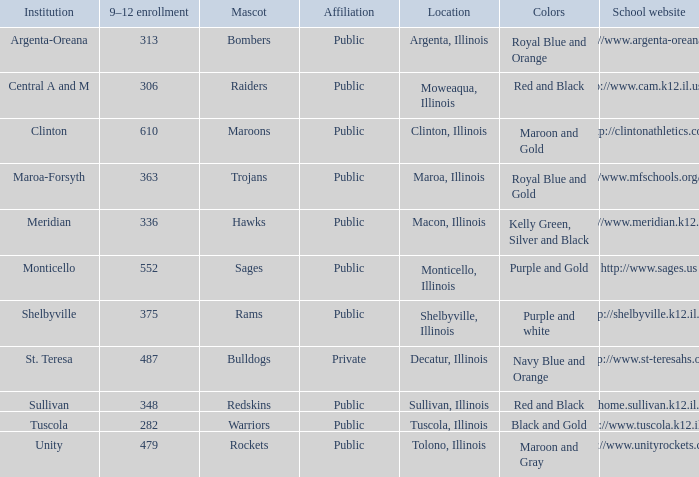Can you parse all the data within this table? {'header': ['Institution', '9–12 enrollment', 'Mascot', 'Affiliation', 'Location', 'Colors', 'School website'], 'rows': [['Argenta-Oreana', '313', 'Bombers', 'Public', 'Argenta, Illinois', 'Royal Blue and Orange', 'http://www.argenta-oreana.org'], ['Central A and M', '306', 'Raiders', 'Public', 'Moweaqua, Illinois', 'Red and Black', 'http://www.cam.k12.il.us/hs'], ['Clinton', '610', 'Maroons', 'Public', 'Clinton, Illinois', 'Maroon and Gold', 'http://clintonathletics.com'], ['Maroa-Forsyth', '363', 'Trojans', 'Public', 'Maroa, Illinois', 'Royal Blue and Gold', 'http://www.mfschools.org/high/'], ['Meridian', '336', 'Hawks', 'Public', 'Macon, Illinois', 'Kelly Green, Silver and Black', 'http://www.meridian.k12.il.us/'], ['Monticello', '552', 'Sages', 'Public', 'Monticello, Illinois', 'Purple and Gold', 'http://www.sages.us'], ['Shelbyville', '375', 'Rams', 'Public', 'Shelbyville, Illinois', 'Purple and white', 'http://shelbyville.k12.il.us/'], ['St. Teresa', '487', 'Bulldogs', 'Private', 'Decatur, Illinois', 'Navy Blue and Orange', 'http://www.st-teresahs.org/'], ['Sullivan', '348', 'Redskins', 'Public', 'Sullivan, Illinois', 'Red and Black', 'http://home.sullivan.k12.il.us/shs'], ['Tuscola', '282', 'Warriors', 'Public', 'Tuscola, Illinois', 'Black and Gold', 'http://www.tuscola.k12.il.us/'], ['Unity', '479', 'Rockets', 'Public', 'Tolono, Illinois', 'Maroon and Gray', 'http://www.unityrockets.com/']]} What colors can you see players from Tolono, Illinois wearing? Maroon and Gray. 